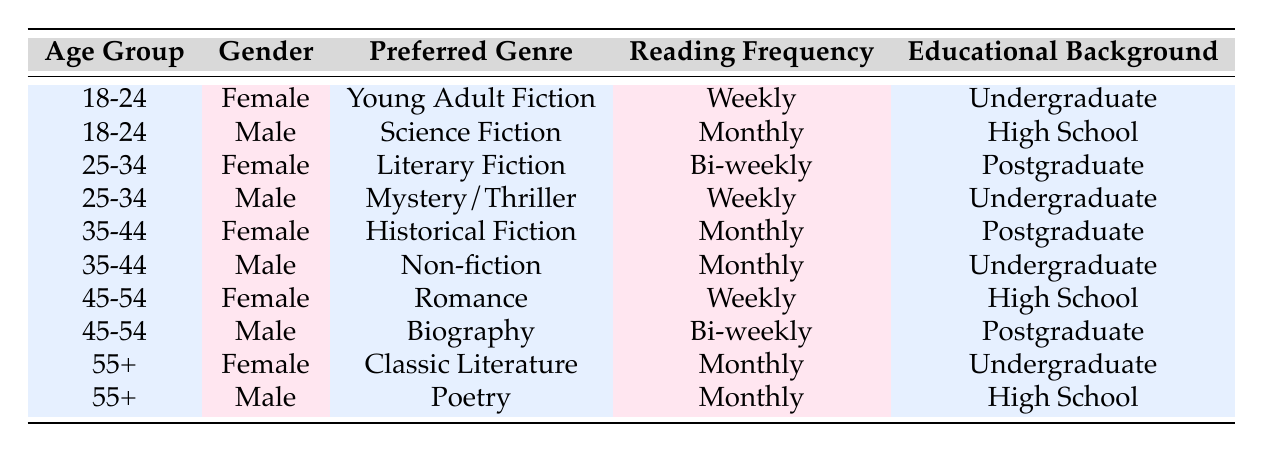What is the preferred genre of females aged 18-24? The table lists the preferences of readers by age group and gender. For the age group 18-24, the preferred genre for females is Young Adult Fiction.
Answer: Young Adult Fiction How often do males aged 35-44 read? The table indicates the reading frequency for males in the age group 35-44 is Monthly, as listed in their respective row.
Answer: Monthly Are there any readers aged 45-54 who prefer Historical Fiction? The table does not show any data for readers aged 45-54 preferring Historical Fiction; this genre is only associated with the 35-44 age group.
Answer: No What is the educational background of the male reader who prefers Science Fiction? By examining the row for the male reader aged 18-24, we see the educational background is High School.
Answer: High School What is the reading frequency for the reader who prefers Literary Fiction? The table indicates that the reading frequency for the female reader aged 25-34, who prefers Literary Fiction, is Bi-weekly.
Answer: Bi-weekly What percentage of males in the table prefer a Weekly reading frequency? There are 5 male readers in total, and 2 of them read weekly (one in the 25-34 age group and the other in the 45-54 age group). The percentage is calculated as (2/5) * 100 = 40%.
Answer: 40% Is there a correlation between educational background and reading frequency for females aged 45-54? The data shows that females aged 45-54 with a High School education read Weekly, while none with a Postgraduate education are listed for that age group. Thus, we conclude that there is no correlation here due to a lack of sufficient data points.
Answer: No What is the difference in preferred genres between males aged 25-34 and 35-44? Males aged 25-34 prefer Mystery/Thriller, while those aged 35-44 prefer Non-fiction. Since these are distinct genres, the difference is simply that the genres are not the same.
Answer: They prefer different genres Which age group has the highest frequency of Weekly reading? By reviewing the data for reading frequency, we find two age groups: 18-24 and 45-54, both have a Weekly frequency for female readers. Thus, both age groups exhibit this highest frequency.
Answer: 18-24 and 45-54 